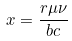Convert formula to latex. <formula><loc_0><loc_0><loc_500><loc_500>x = \frac { r \mu \nu } { b c }</formula> 